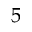Convert formula to latex. <formula><loc_0><loc_0><loc_500><loc_500>5</formula> 